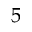Convert formula to latex. <formula><loc_0><loc_0><loc_500><loc_500>5</formula> 